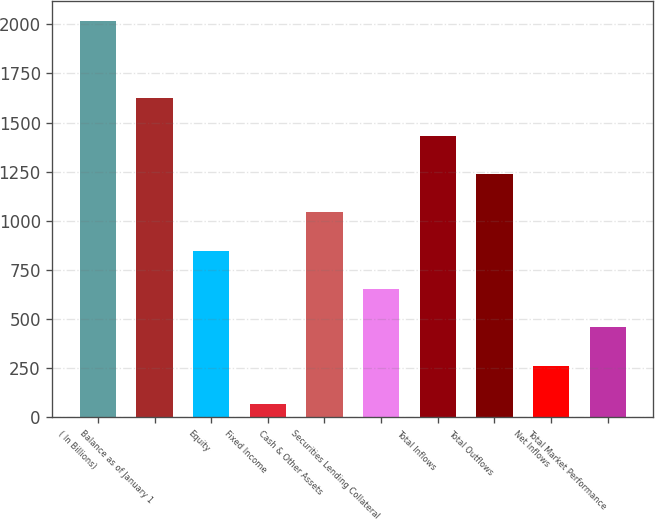Convert chart. <chart><loc_0><loc_0><loc_500><loc_500><bar_chart><fcel>( In Billions)<fcel>Balance as of January 1<fcel>Equity<fcel>Fixed Income<fcel>Cash & Other Assets<fcel>Securities Lending Collateral<fcel>Total Inflows<fcel>Total Outflows<fcel>Net Inflows<fcel>Total Market Performance<nl><fcel>2017<fcel>1627.22<fcel>847.66<fcel>68.1<fcel>1042.55<fcel>652.77<fcel>1432.33<fcel>1237.44<fcel>262.99<fcel>457.88<nl></chart> 